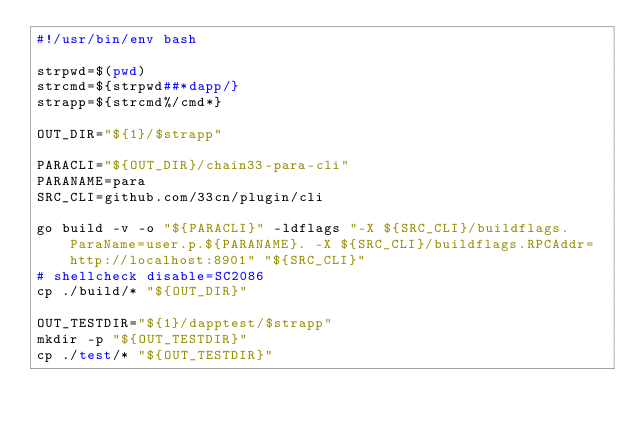<code> <loc_0><loc_0><loc_500><loc_500><_Bash_>#!/usr/bin/env bash

strpwd=$(pwd)
strcmd=${strpwd##*dapp/}
strapp=${strcmd%/cmd*}

OUT_DIR="${1}/$strapp"

PARACLI="${OUT_DIR}/chain33-para-cli"
PARANAME=para
SRC_CLI=github.com/33cn/plugin/cli

go build -v -o "${PARACLI}" -ldflags "-X ${SRC_CLI}/buildflags.ParaName=user.p.${PARANAME}. -X ${SRC_CLI}/buildflags.RPCAddr=http://localhost:8901" "${SRC_CLI}"
# shellcheck disable=SC2086
cp ./build/* "${OUT_DIR}"

OUT_TESTDIR="${1}/dapptest/$strapp"
mkdir -p "${OUT_TESTDIR}"
cp ./test/* "${OUT_TESTDIR}"
</code> 